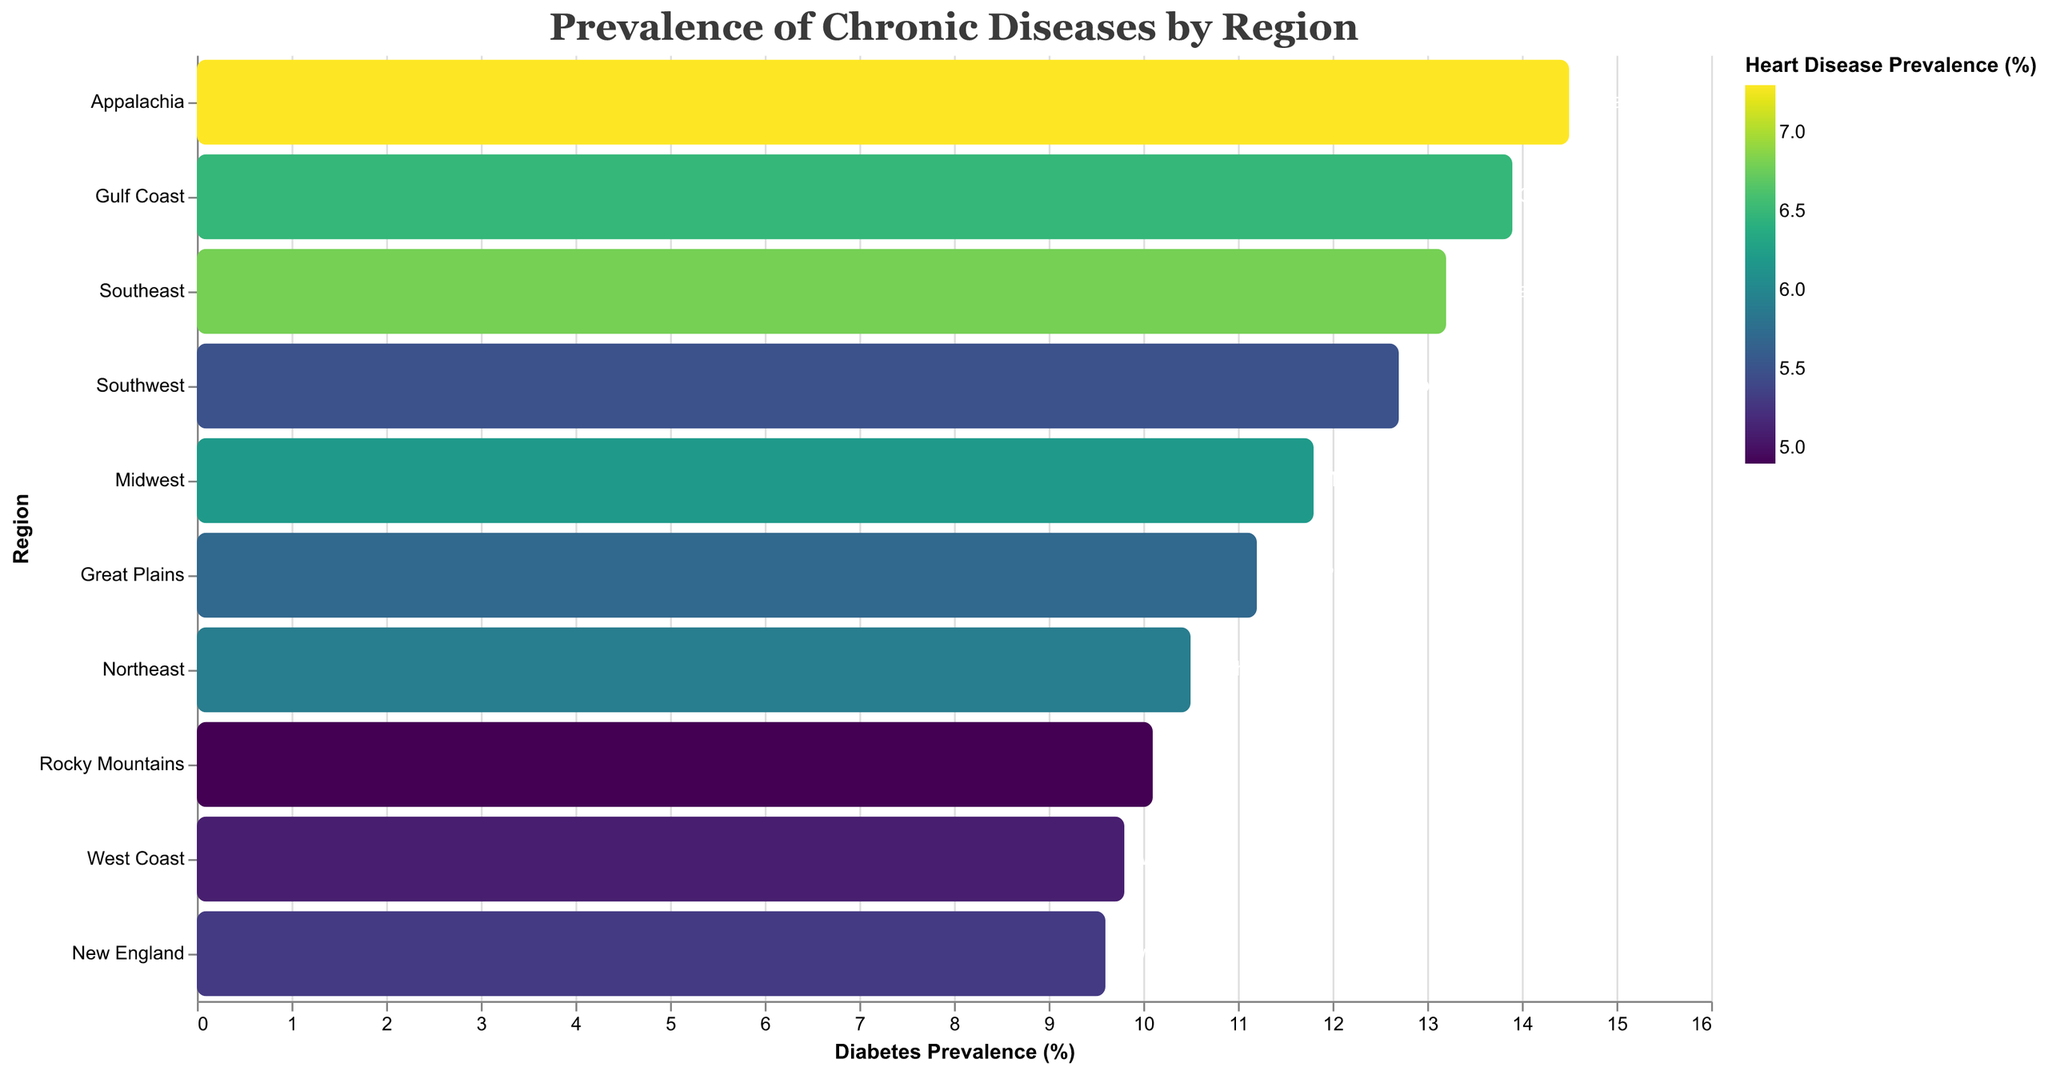What region has the highest diabetes prevalence? The bar representing Appalachia is the longest among the regions, indicating it has the highest value for diabetes prevalence.
Answer: Appalachia What is the title of the figure? The title is displayed at the top of the figure, specifying the main subject. It reads "Prevalence of Chronic Diseases by Region."
Answer: Prevalence of Chronic Diseases by Region Which region has the lowest heart disease prevalence? The color intensity of the bars represents heart disease prevalence; lighter colors indicate lower prevalence. The Rocky Mountains region has the lightest color.
Answer: Rocky Mountains What is the difference in diabetes prevalence between the Southeast and the West Coast? The Southeast has a diabetes prevalence of 13.2%, and the West Coast has 9.8%. Subtracting the two gives: 13.2% - 9.8% = 3.4%.
Answer: 3.4% What regions have a diabetes prevalence greater than 12%? The bars that exceed the 12% mark on the x-axis are from the Southeast, Southwest, Appalachia, and Gulf Coast regions.
Answer: Southeast, Southwest, Appalachia, Gulf Coast Which region has both a low diabetes and heart disease prevalence? A low diabetes prevalence (<10%) and light bar color indicate both low prevalences. The West Coast and New England regions meet this criterion.
Answer: West Coast, New England What is the average diabetes prevalence across all regions? Summing up all diabetes prevalence values and dividing by the number of regions: (13.2 + 10.5 + 11.8 + 12.7 + 9.8 + 14.5 + 11.2 + 9.6 + 13.9 + 10.1) / 10 = 11.73%.
Answer: 11.73% How does Appalachia's heart disease prevalence compare to the Great Plains? Appalachia has a heart disease prevalence of 7.3%, while the Great Plains has 5.7%. Comparing these values, 7.3% > 5.7%.
Answer: Appalachia has a higher prevalence What pattern can be observed in the regions with higher diabetes prevalence regarding heart disease prevalence? Regions with higher diabetes prevalence (Southeast, Appalachia, Gulf Coast) also show higher color intensity, indicating higher heart disease prevalence.
Answer: Higher diabetes prevalence correlates with higher heart disease prevalence 